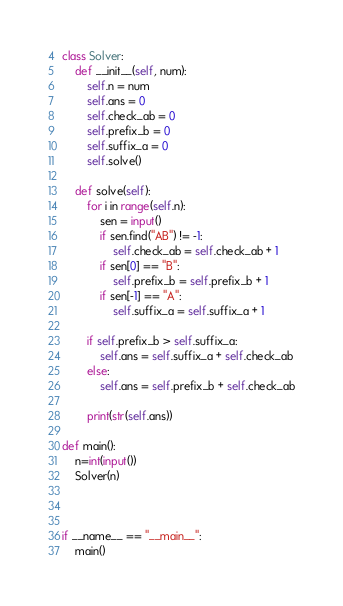<code> <loc_0><loc_0><loc_500><loc_500><_Python_>class Solver:
    def __init__(self, num):
        self.n = num
        self.ans = 0
        self.check_ab = 0
        self.prefix_b = 0
        self.suffix_a = 0
        self.solve()
    
    def solve(self):
        for i in range(self.n):
            sen = input()
            if sen.find("AB") != -1:
                self.check_ab = self.check_ab + 1
            if sen[0] == "B":
                self.prefix_b = self.prefix_b + 1
            if sen[-1] == "A":
                self.suffix_a = self.suffix_a + 1
        
        if self.prefix_b > self.suffix_a:
            self.ans = self.suffix_a + self.check_ab
        else:
            self.ans = self.prefix_b + self.check_ab

        print(str(self.ans))

def main():
    n=int(input())
    Solver(n)



if __name__ == "__main__":
    main()</code> 